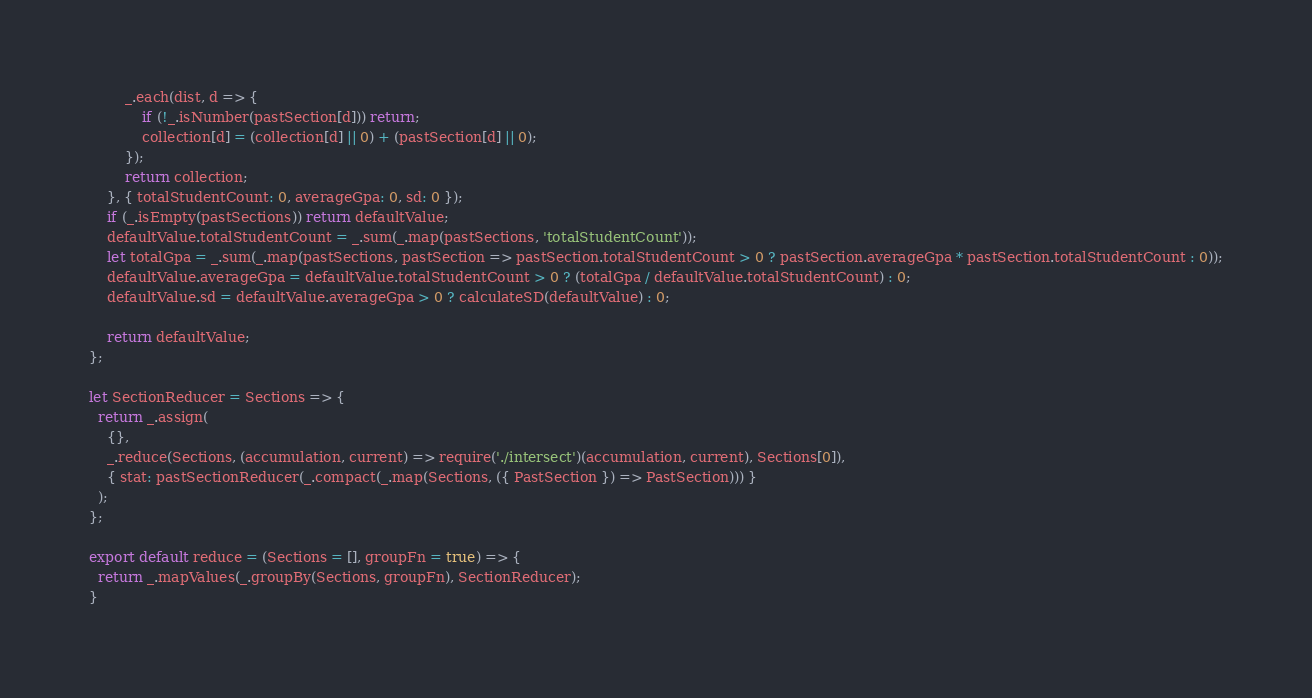Convert code to text. <code><loc_0><loc_0><loc_500><loc_500><_JavaScript_>        _.each(dist, d => {
            if (!_.isNumber(pastSection[d])) return;
            collection[d] = (collection[d] || 0) + (pastSection[d] || 0);
        });
        return collection;
    }, { totalStudentCount: 0, averageGpa: 0, sd: 0 });
    if (_.isEmpty(pastSections)) return defaultValue;
    defaultValue.totalStudentCount = _.sum(_.map(pastSections, 'totalStudentCount'));
    let totalGpa = _.sum(_.map(pastSections, pastSection => pastSection.totalStudentCount > 0 ? pastSection.averageGpa * pastSection.totalStudentCount : 0));
    defaultValue.averageGpa = defaultValue.totalStudentCount > 0 ? (totalGpa / defaultValue.totalStudentCount) : 0;
    defaultValue.sd = defaultValue.averageGpa > 0 ? calculateSD(defaultValue) : 0;

    return defaultValue;
};

let SectionReducer = Sections => {
  return _.assign(
    {},
    _.reduce(Sections, (accumulation, current) => require('./intersect')(accumulation, current), Sections[0]),
    { stat: pastSectionReducer(_.compact(_.map(Sections, ({ PastSection }) => PastSection))) }
  );
};

export default reduce = (Sections = [], groupFn = true) => {
  return _.mapValues(_.groupBy(Sections, groupFn), SectionReducer);
}</code> 